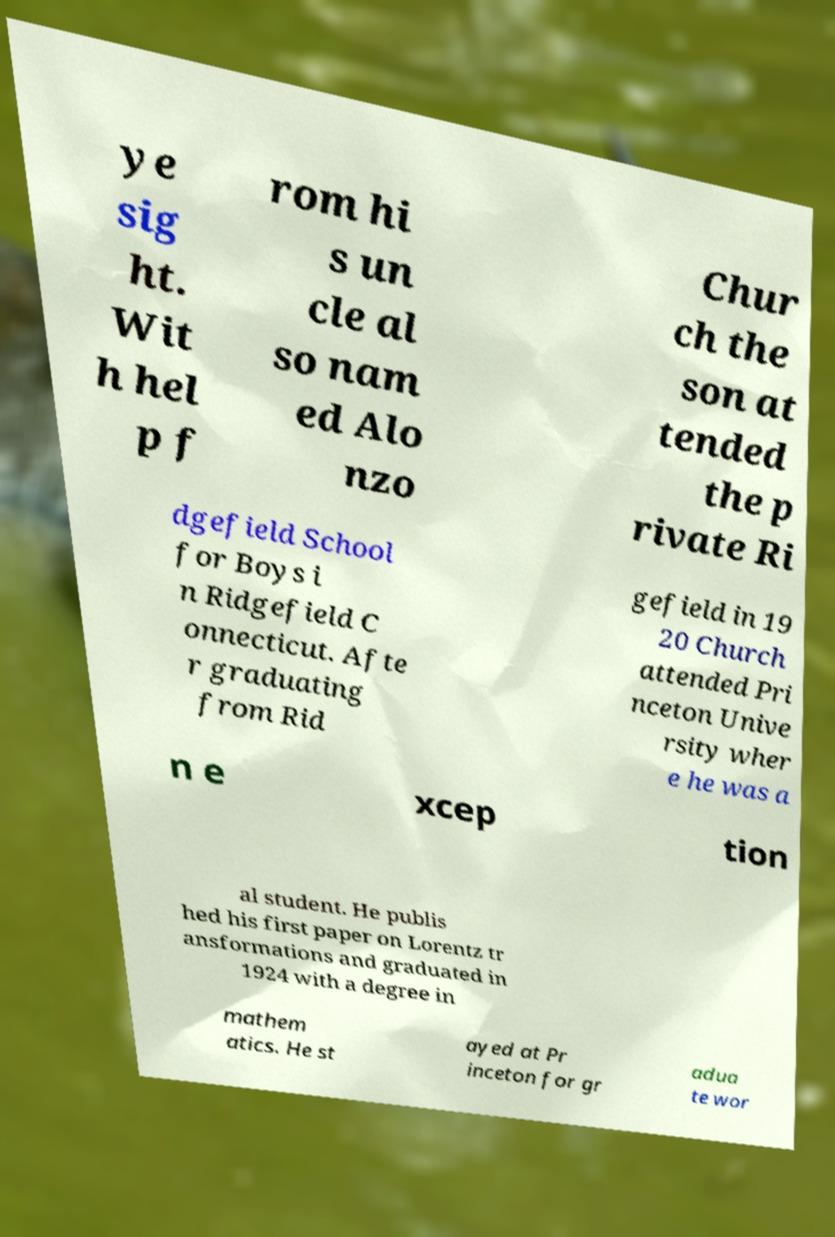Can you accurately transcribe the text from the provided image for me? ye sig ht. Wit h hel p f rom hi s un cle al so nam ed Alo nzo Chur ch the son at tended the p rivate Ri dgefield School for Boys i n Ridgefield C onnecticut. Afte r graduating from Rid gefield in 19 20 Church attended Pri nceton Unive rsity wher e he was a n e xcep tion al student. He publis hed his first paper on Lorentz tr ansformations and graduated in 1924 with a degree in mathem atics. He st ayed at Pr inceton for gr adua te wor 